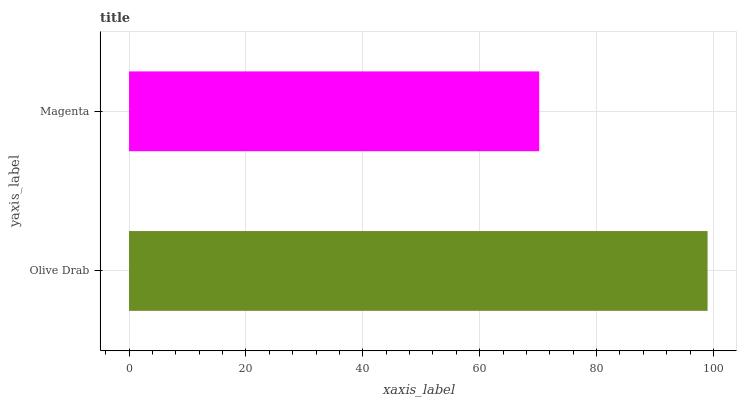Is Magenta the minimum?
Answer yes or no. Yes. Is Olive Drab the maximum?
Answer yes or no. Yes. Is Magenta the maximum?
Answer yes or no. No. Is Olive Drab greater than Magenta?
Answer yes or no. Yes. Is Magenta less than Olive Drab?
Answer yes or no. Yes. Is Magenta greater than Olive Drab?
Answer yes or no. No. Is Olive Drab less than Magenta?
Answer yes or no. No. Is Olive Drab the high median?
Answer yes or no. Yes. Is Magenta the low median?
Answer yes or no. Yes. Is Magenta the high median?
Answer yes or no. No. Is Olive Drab the low median?
Answer yes or no. No. 